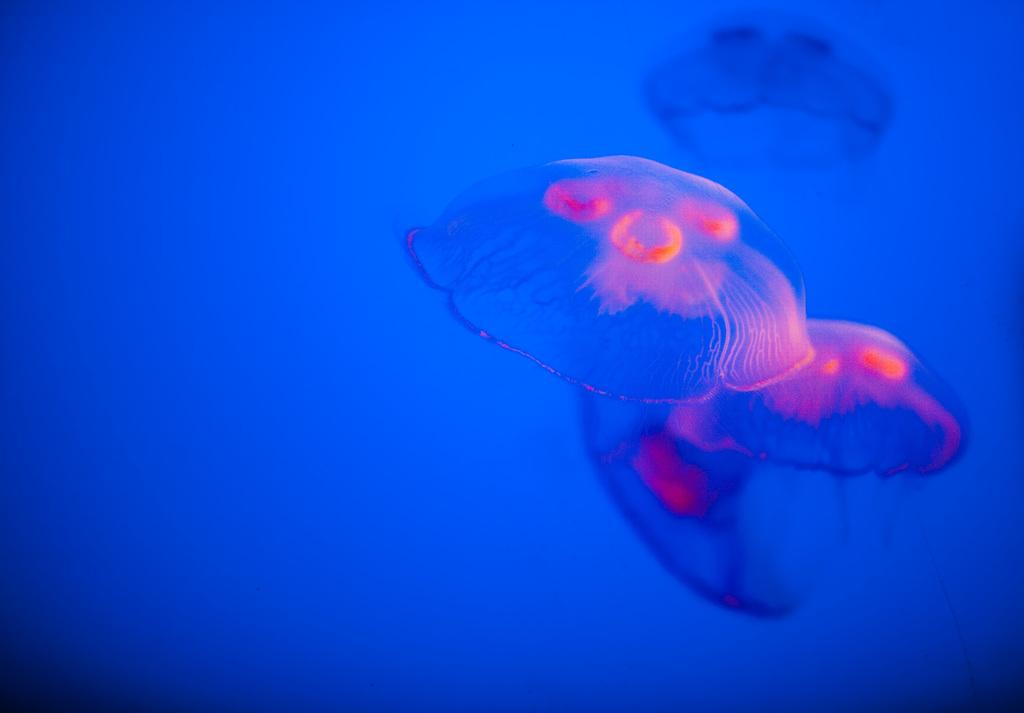What is the main subject of the image? There is a colorful object in the image. What type of arch can be seen supporting the corn in the image? There is no arch or corn present in the image; it only features a colorful object. 